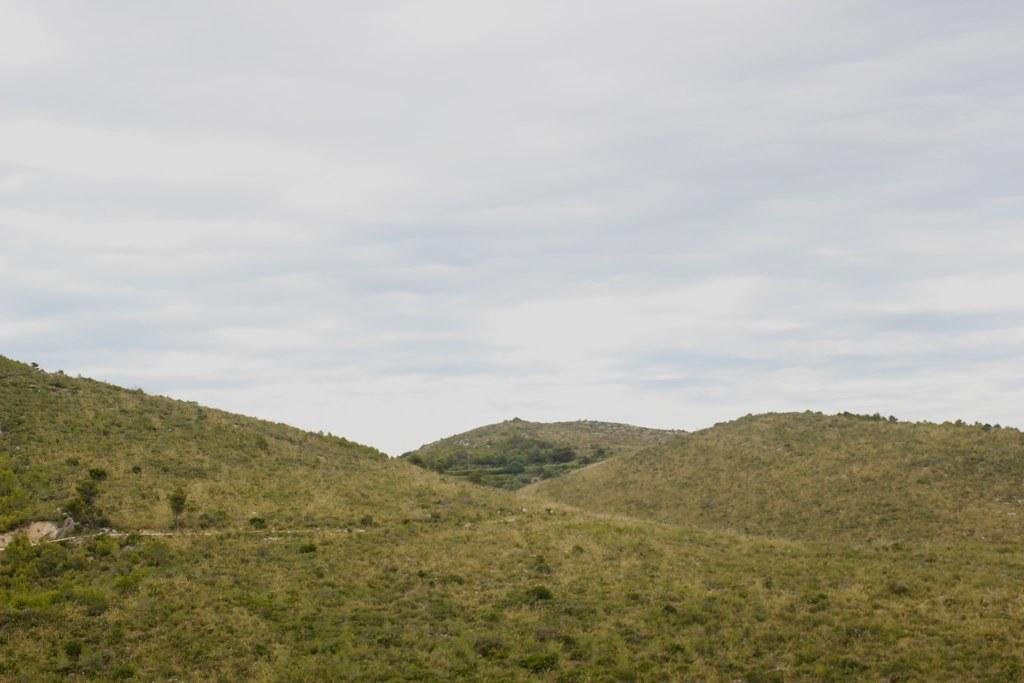Could you give a brief overview of what you see in this image? In this picture we can see some grass on the ground. There are a few plants, trees and some greenery is visible in the background. Sky is cloudy. 